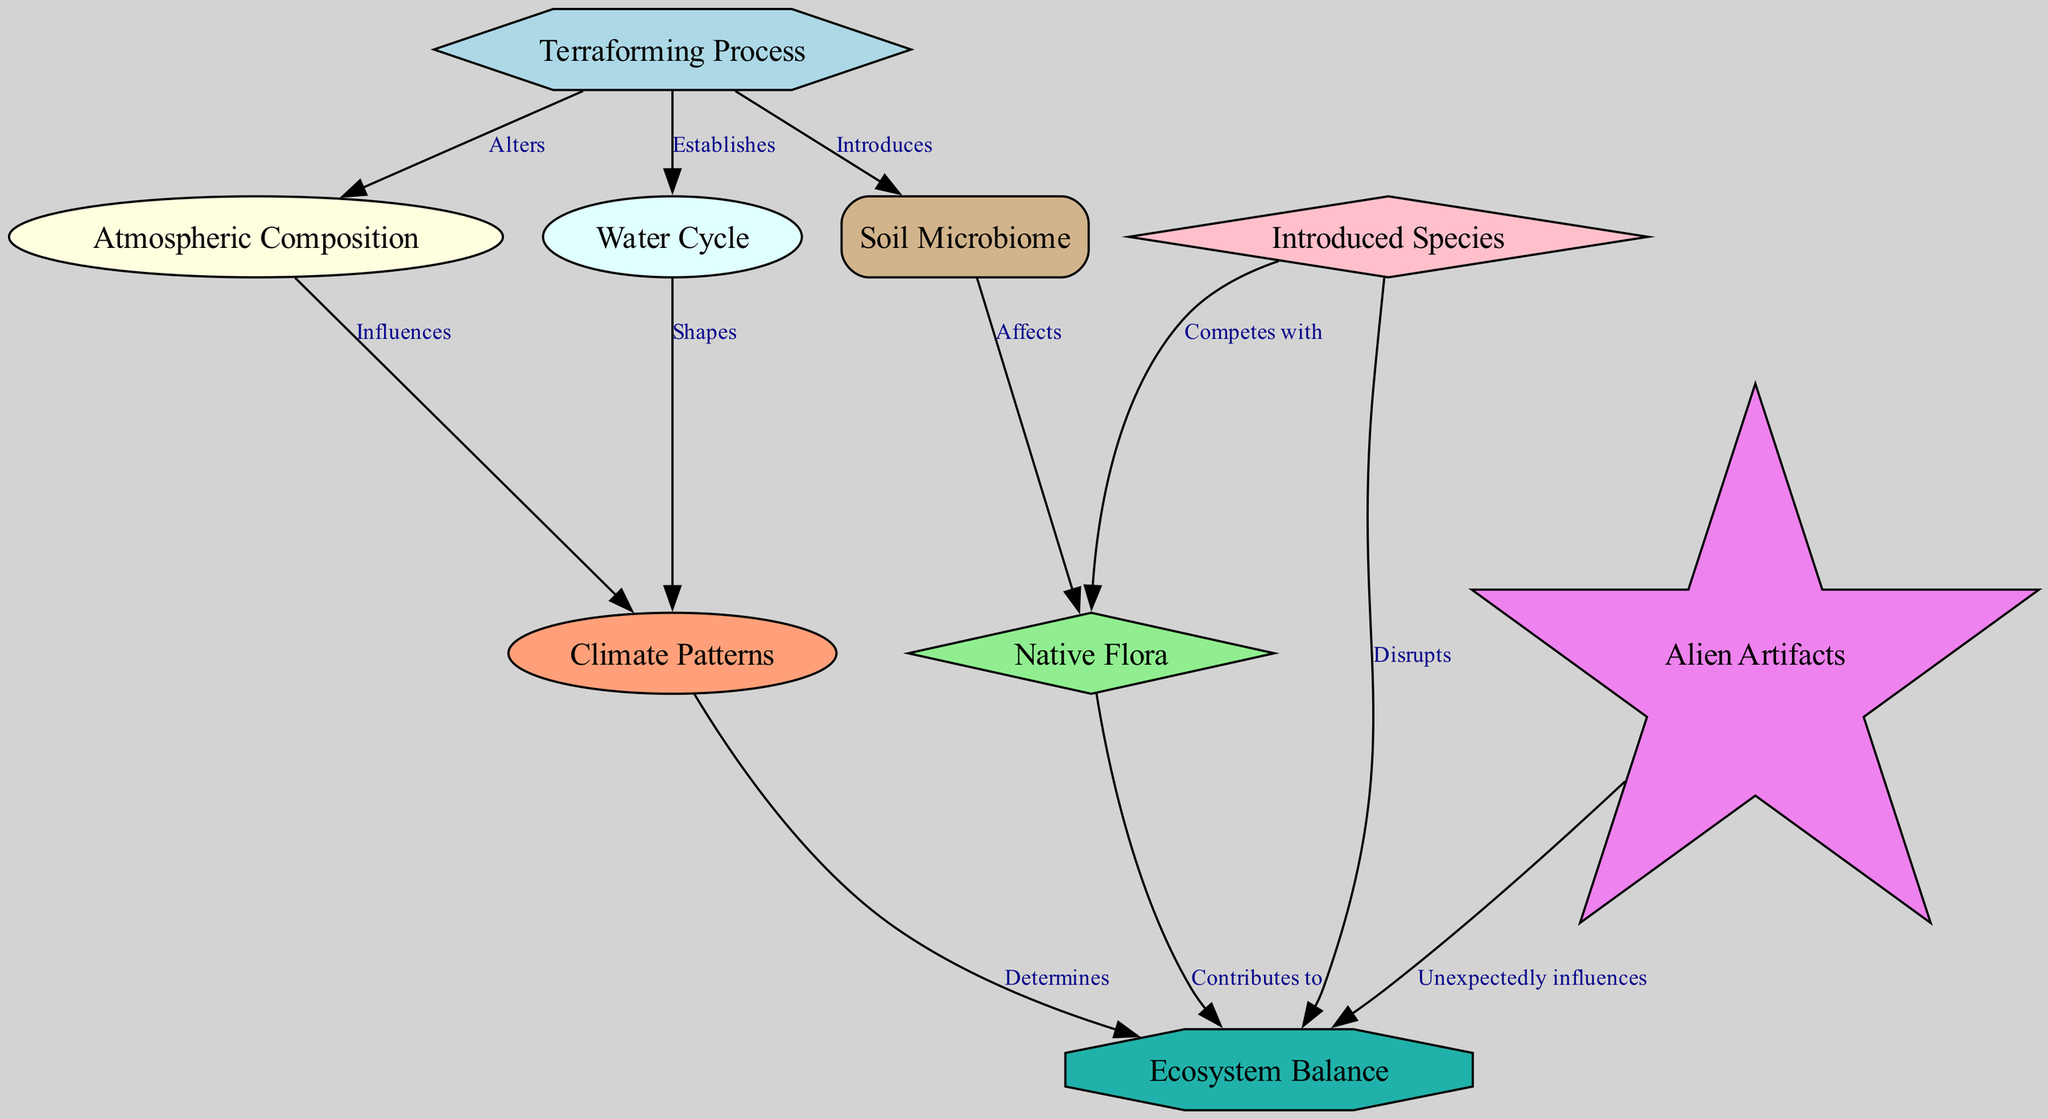How many nodes are in the diagram? The diagram contains a total of 9 nodes, which are the different aspects of ecological changes: Terraforming Process, Atmospheric Composition, Water Cycle, Soil Microbiome, Native Flora, Introduced Species, Climate Patterns, Ecosystem Balance, and Alien Artifacts.
Answer: 9 What relationship exists between "Terraforming Process" and "Atmospheric Composition"? The edge labeled "Alters" connects "Terraforming Process" to "Atmospheric Composition", indicating a direct influence of the terraforming on the planet's atmospheric characteristics.
Answer: Alters Which entity competes with "Native Flora"? The diagram shows that "Introduced Species" competes with "Native Flora", indicated by the edge labeled "Competes with".
Answer: Introduced Species How does "Water Cycle" affect "Climate Patterns"? The edge labeled "Shapes" connects "Water Cycle" to "Climate Patterns", suggesting that the established water cycle on the terraformed planet modulates or shapes the climate conditions.
Answer: Shapes What is the effect of "Atmospheric Composition" on "Climate Patterns"? The edge labeled "Influences" indicates that changes in the atmospheric composition directly influence the climate patterns of the terraformed planet.
Answer: Influences Which two nodes have a direct disruptive effect on "Ecosystem Balance"? "Introduced Species" and "Alien Artifacts" both have edges leading into "Ecosystem Balance" with the labels "Disrupts" and "Unexpectedly influences", respectively.
Answer: Introduced Species, Alien Artifacts What role does "Soil Microbiome" play in the ecosystem? The edge labeled "Affects" between "Soil Microbiome" and "Native Flora" indicates that the soil microbiome significantly affects the native plant life within the ecosystem.
Answer: Affects How many relationships involve "Ecosystem Balance"? The diagram has three edges leading into "Ecosystem Balance", linking it to "Climate Patterns", "Native Flora", and "Introduced Species", thus showing its interconnectedness with these factors.
Answer: 3 